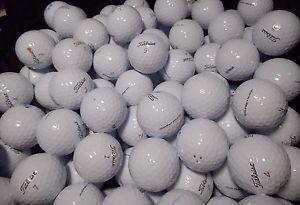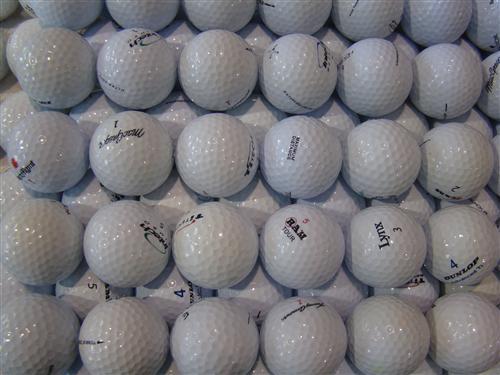The first image is the image on the left, the second image is the image on the right. Analyze the images presented: Is the assertion "Right and left images show only clean-looking white balls." valid? Answer yes or no. Yes. 